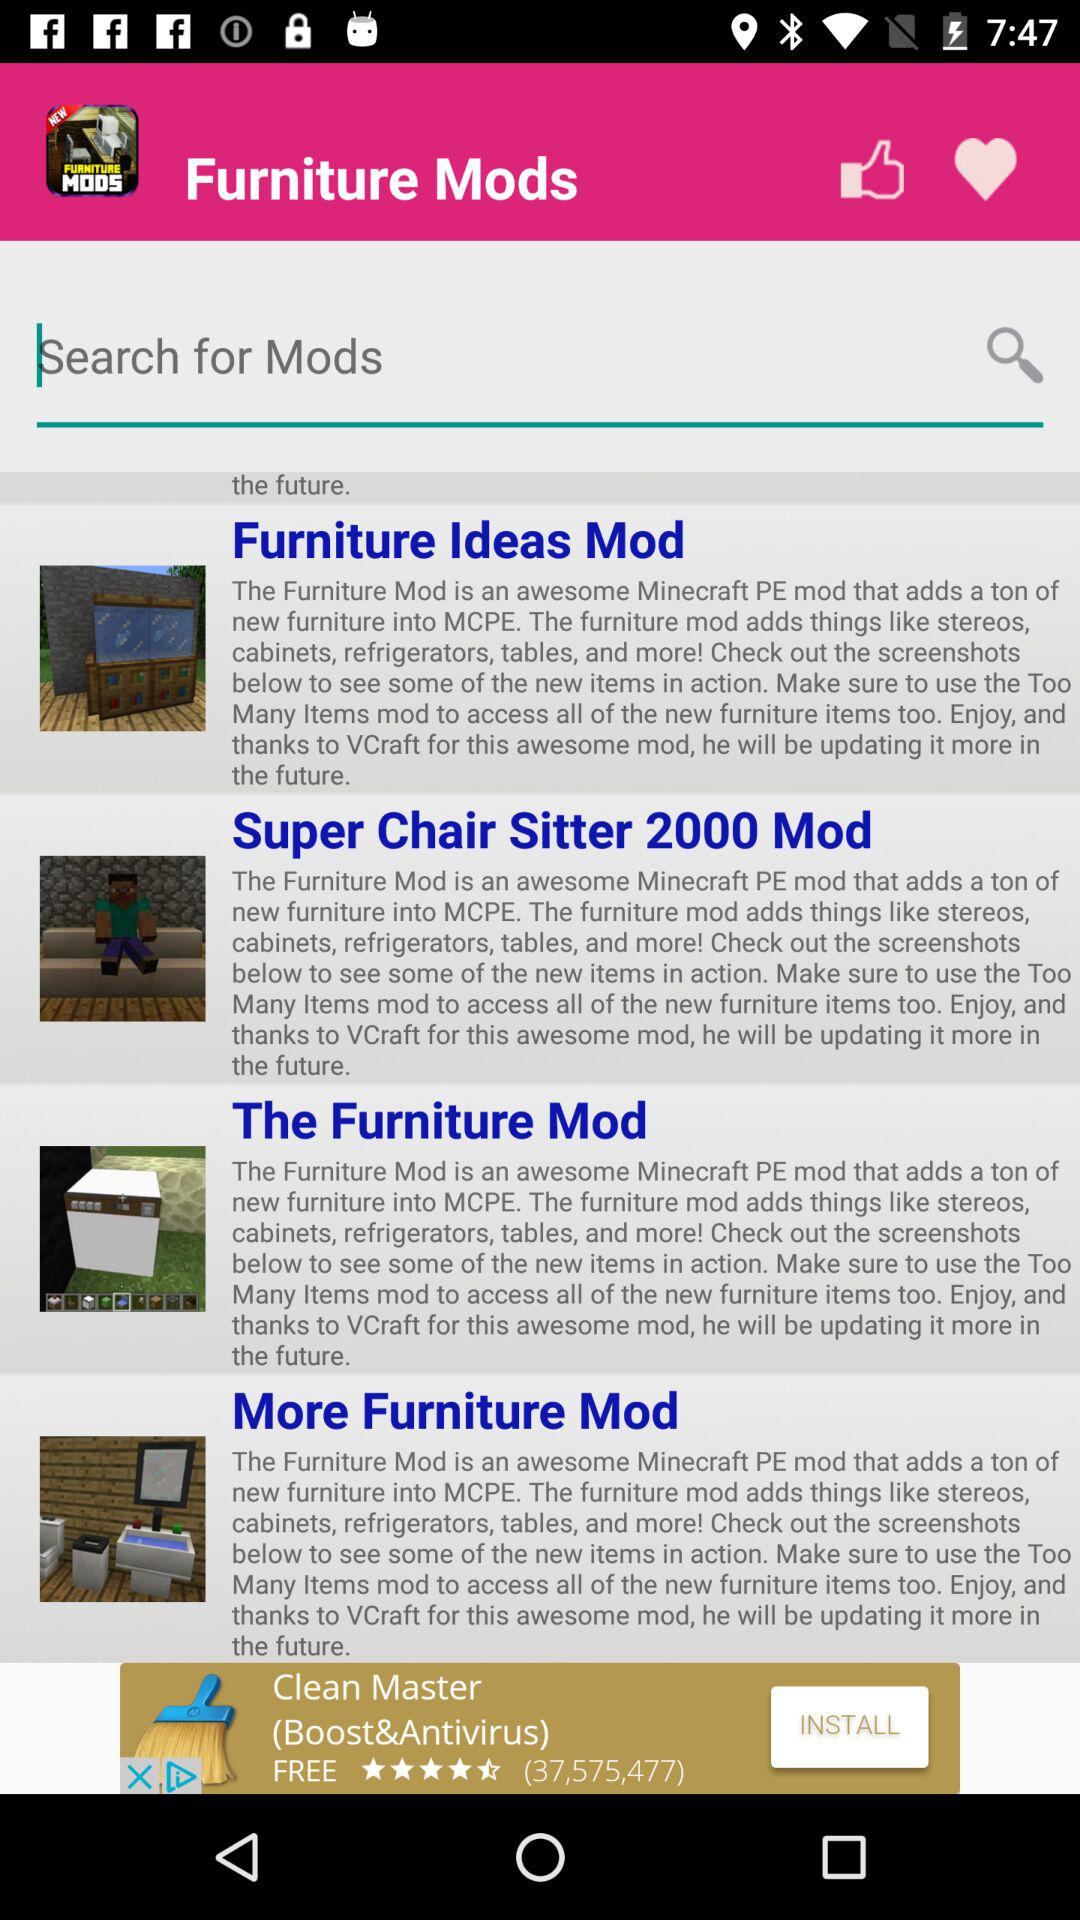How many furniture mods are there?
Answer the question using a single word or phrase. 4 